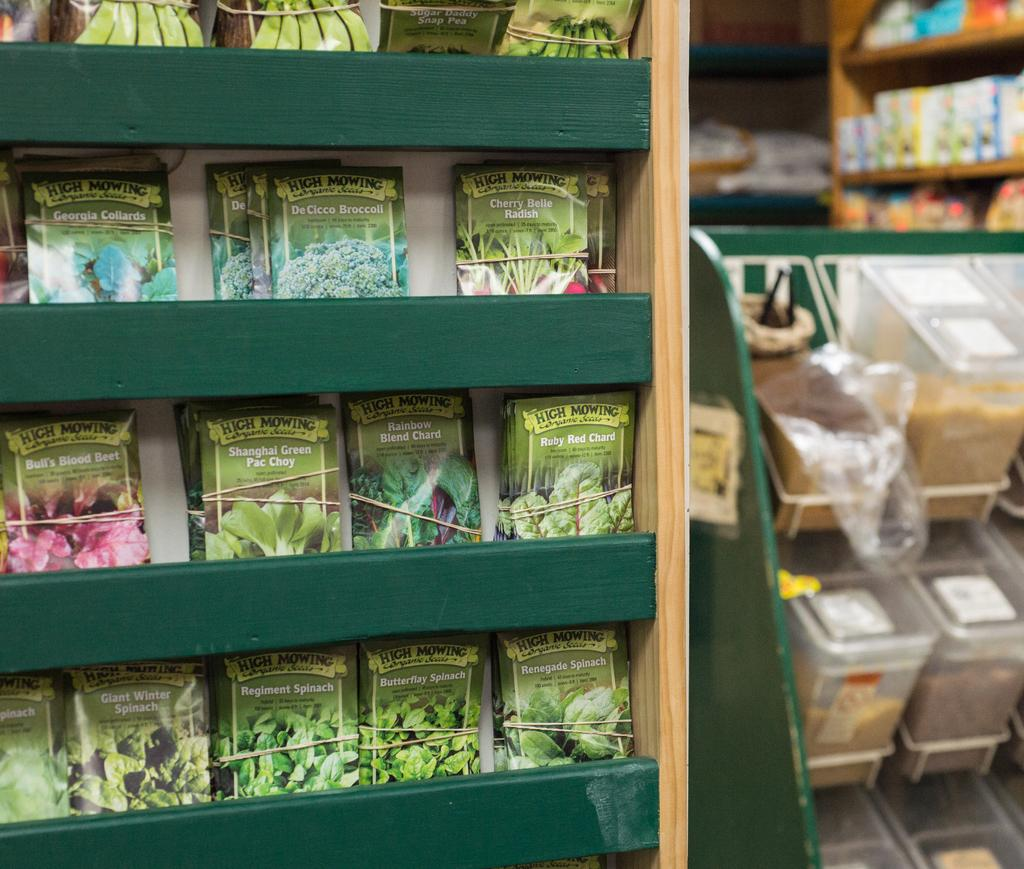<image>
Summarize the visual content of the image. A rack filled with a variety of different seeds to grow plants or vegetables like green pac choy. 